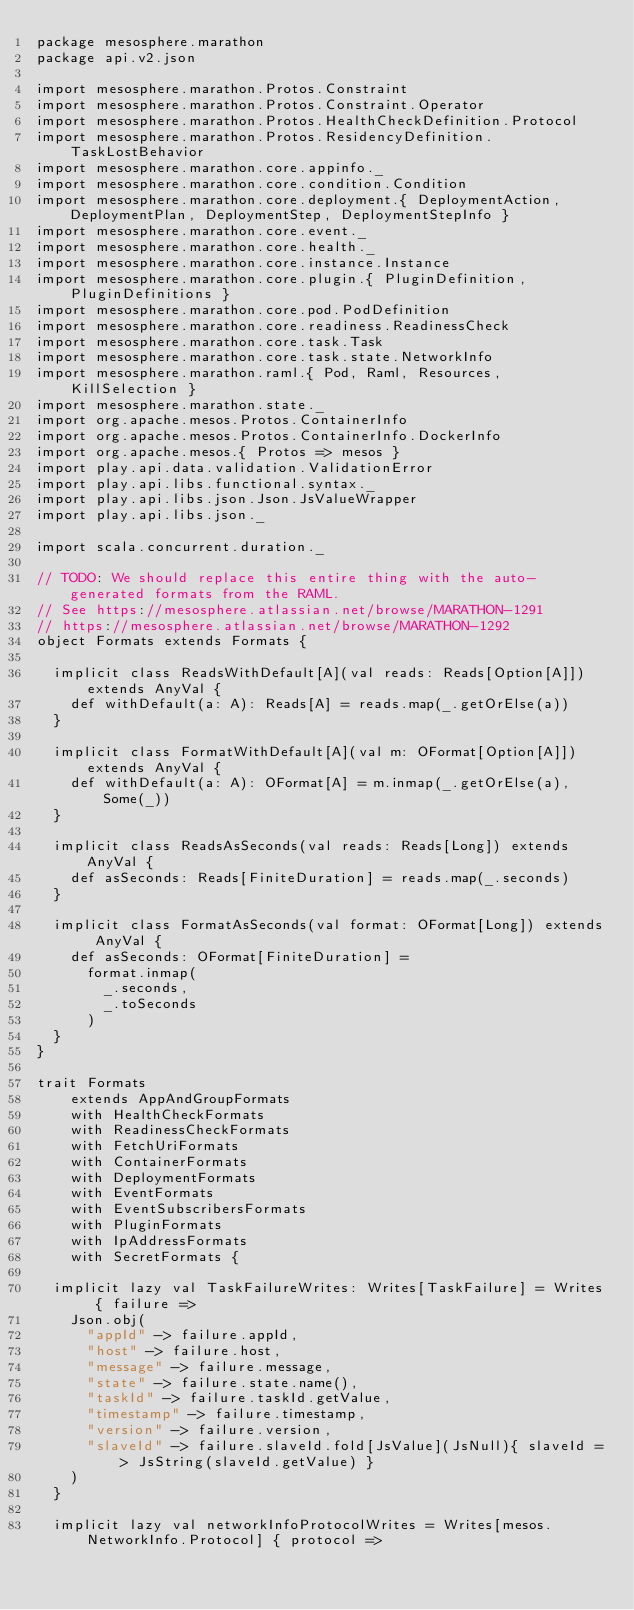<code> <loc_0><loc_0><loc_500><loc_500><_Scala_>package mesosphere.marathon
package api.v2.json

import mesosphere.marathon.Protos.Constraint
import mesosphere.marathon.Protos.Constraint.Operator
import mesosphere.marathon.Protos.HealthCheckDefinition.Protocol
import mesosphere.marathon.Protos.ResidencyDefinition.TaskLostBehavior
import mesosphere.marathon.core.appinfo._
import mesosphere.marathon.core.condition.Condition
import mesosphere.marathon.core.deployment.{ DeploymentAction, DeploymentPlan, DeploymentStep, DeploymentStepInfo }
import mesosphere.marathon.core.event._
import mesosphere.marathon.core.health._
import mesosphere.marathon.core.instance.Instance
import mesosphere.marathon.core.plugin.{ PluginDefinition, PluginDefinitions }
import mesosphere.marathon.core.pod.PodDefinition
import mesosphere.marathon.core.readiness.ReadinessCheck
import mesosphere.marathon.core.task.Task
import mesosphere.marathon.core.task.state.NetworkInfo
import mesosphere.marathon.raml.{ Pod, Raml, Resources, KillSelection }
import mesosphere.marathon.state._
import org.apache.mesos.Protos.ContainerInfo
import org.apache.mesos.Protos.ContainerInfo.DockerInfo
import org.apache.mesos.{ Protos => mesos }
import play.api.data.validation.ValidationError
import play.api.libs.functional.syntax._
import play.api.libs.json.Json.JsValueWrapper
import play.api.libs.json._

import scala.concurrent.duration._

// TODO: We should replace this entire thing with the auto-generated formats from the RAML.
// See https://mesosphere.atlassian.net/browse/MARATHON-1291
// https://mesosphere.atlassian.net/browse/MARATHON-1292
object Formats extends Formats {

  implicit class ReadsWithDefault[A](val reads: Reads[Option[A]]) extends AnyVal {
    def withDefault(a: A): Reads[A] = reads.map(_.getOrElse(a))
  }

  implicit class FormatWithDefault[A](val m: OFormat[Option[A]]) extends AnyVal {
    def withDefault(a: A): OFormat[A] = m.inmap(_.getOrElse(a), Some(_))
  }

  implicit class ReadsAsSeconds(val reads: Reads[Long]) extends AnyVal {
    def asSeconds: Reads[FiniteDuration] = reads.map(_.seconds)
  }

  implicit class FormatAsSeconds(val format: OFormat[Long]) extends AnyVal {
    def asSeconds: OFormat[FiniteDuration] =
      format.inmap(
        _.seconds,
        _.toSeconds
      )
  }
}

trait Formats
    extends AppAndGroupFormats
    with HealthCheckFormats
    with ReadinessCheckFormats
    with FetchUriFormats
    with ContainerFormats
    with DeploymentFormats
    with EventFormats
    with EventSubscribersFormats
    with PluginFormats
    with IpAddressFormats
    with SecretFormats {

  implicit lazy val TaskFailureWrites: Writes[TaskFailure] = Writes { failure =>
    Json.obj(
      "appId" -> failure.appId,
      "host" -> failure.host,
      "message" -> failure.message,
      "state" -> failure.state.name(),
      "taskId" -> failure.taskId.getValue,
      "timestamp" -> failure.timestamp,
      "version" -> failure.version,
      "slaveId" -> failure.slaveId.fold[JsValue](JsNull){ slaveId => JsString(slaveId.getValue) }
    )
  }

  implicit lazy val networkInfoProtocolWrites = Writes[mesos.NetworkInfo.Protocol] { protocol =></code> 